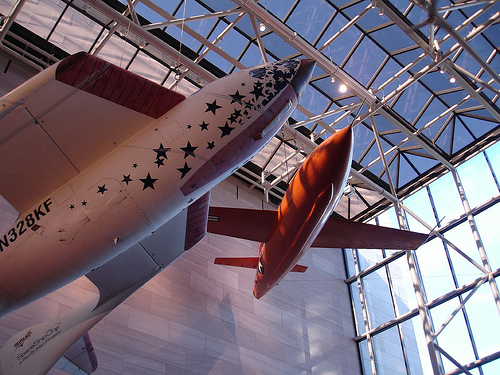<image>
Is there a airplane under the roof? Yes. The airplane is positioned underneath the roof, with the roof above it in the vertical space. 